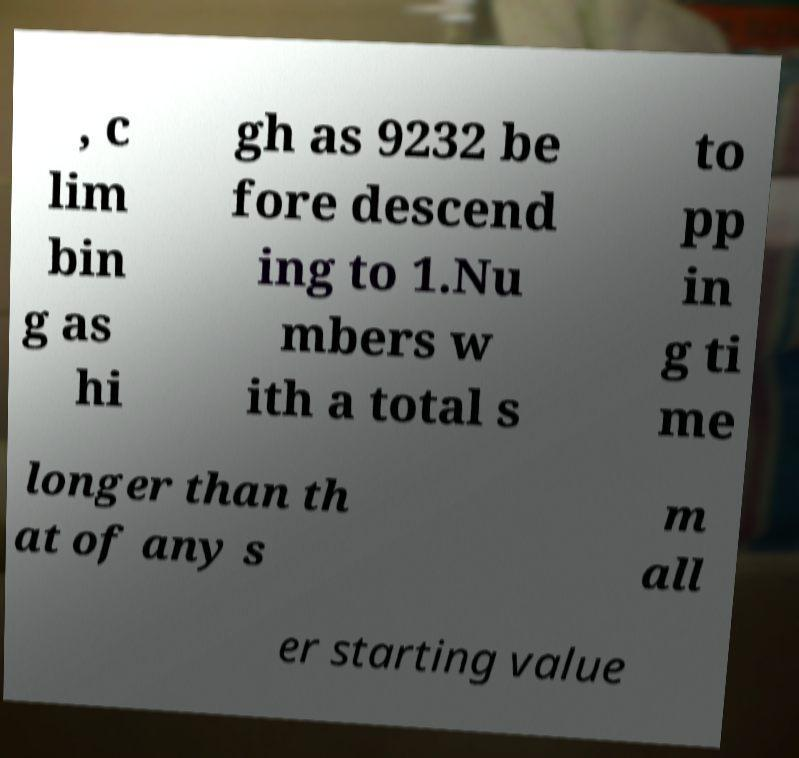Please read and relay the text visible in this image. What does it say? , c lim bin g as hi gh as 9232 be fore descend ing to 1.Nu mbers w ith a total s to pp in g ti me longer than th at of any s m all er starting value 